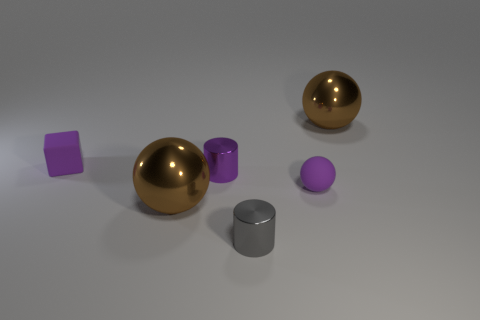Is there a matte object that has the same color as the rubber ball?
Make the answer very short. Yes. There is a matte cube that is behind the tiny purple cylinder; is its size the same as the sphere that is in front of the tiny rubber sphere?
Offer a very short reply. No. What is the size of the shiny thing that is right of the tiny gray metal cylinder?
Offer a terse response. Large. What size is the metallic ball behind the brown metallic object that is in front of the metallic cylinder that is behind the purple sphere?
Provide a succinct answer. Large. What material is the purple thing that is the same shape as the tiny gray object?
Provide a succinct answer. Metal. There is a gray cylinder; are there any metal spheres to the right of it?
Offer a terse response. Yes. How many metallic cylinders are there?
Make the answer very short. 2. What number of purple cylinders are to the right of the large brown metallic object that is on the left side of the tiny gray cylinder?
Offer a very short reply. 1. Is the color of the tiny block the same as the tiny sphere on the right side of the purple rubber block?
Provide a short and direct response. Yes. What number of other tiny shiny things have the same shape as the small purple shiny thing?
Your answer should be compact. 1. 